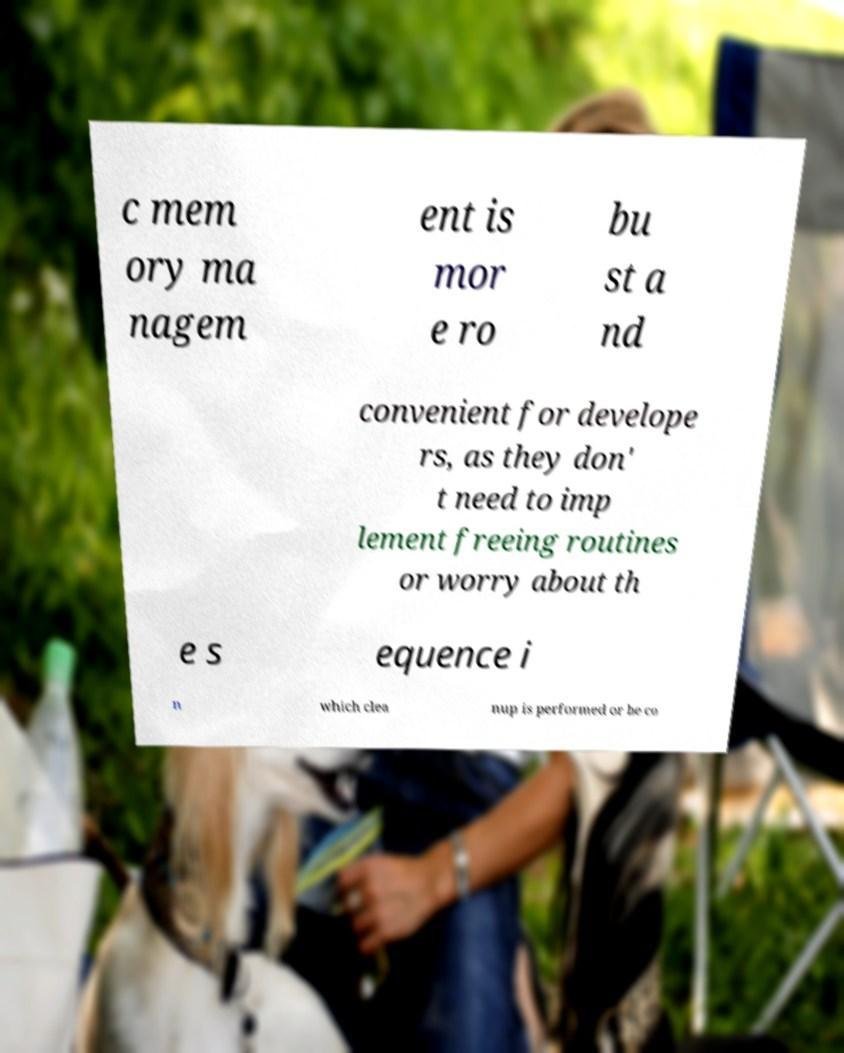There's text embedded in this image that I need extracted. Can you transcribe it verbatim? c mem ory ma nagem ent is mor e ro bu st a nd convenient for develope rs, as they don' t need to imp lement freeing routines or worry about th e s equence i n which clea nup is performed or be co 